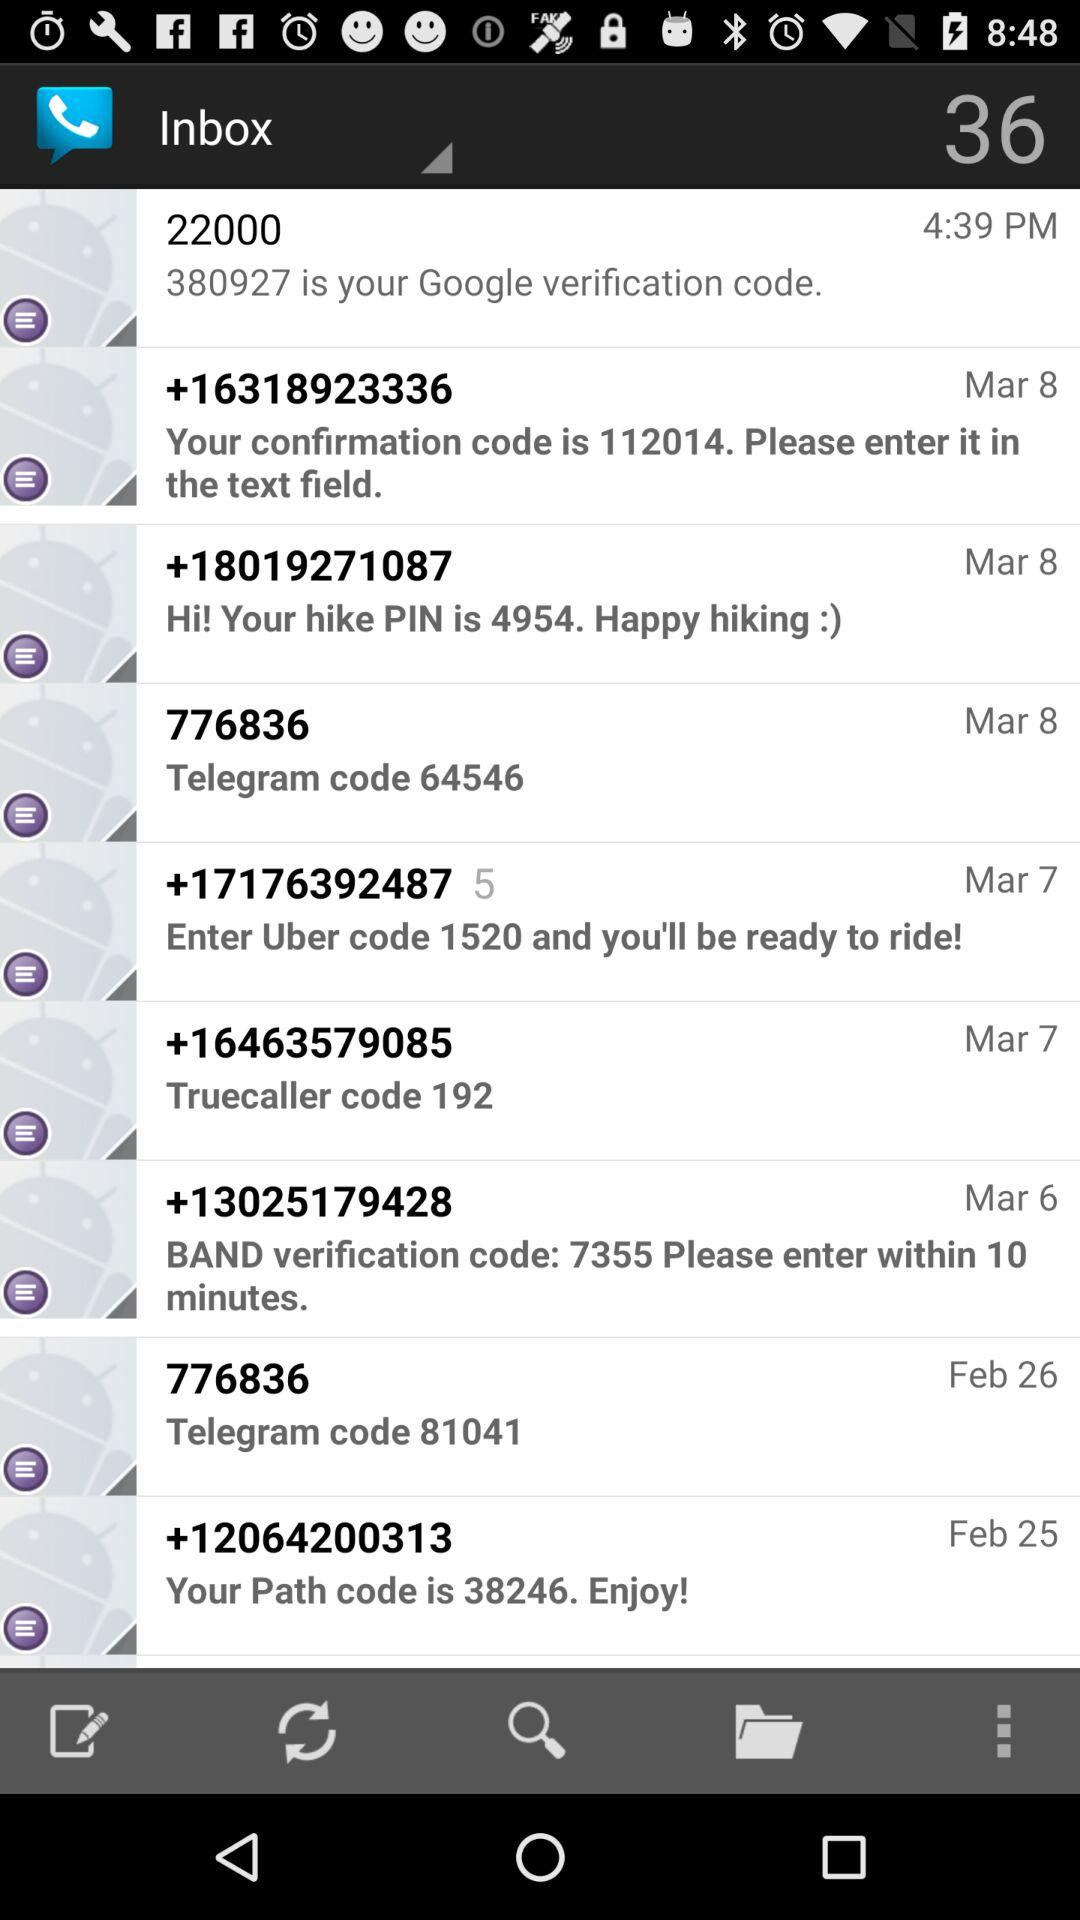Which number sent the "Truecaller" code? The number is +16463579085. 